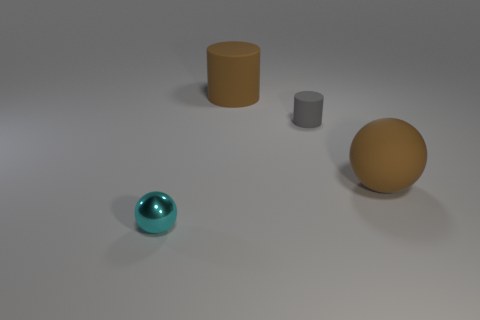Is there any other thing that is the same material as the small cyan sphere?
Offer a terse response. No. How many large cylinders are the same color as the large matte sphere?
Your answer should be compact. 1. Is the color of the large matte object in front of the large brown matte cylinder the same as the big matte cylinder?
Your answer should be very brief. Yes. There is a small cyan shiny object in front of the large brown rubber ball; what shape is it?
Provide a short and direct response. Sphere. Is there a rubber sphere on the left side of the large brown object that is behind the brown sphere?
Provide a short and direct response. No. What number of other small cylinders are made of the same material as the brown cylinder?
Your answer should be very brief. 1. What size is the brown object on the left side of the large rubber sphere that is to the right of the large brown rubber object behind the small matte thing?
Offer a very short reply. Large. How many cylinders are behind the tiny cylinder?
Your response must be concise. 1. Is the number of big brown objects greater than the number of large green metal cubes?
Provide a succinct answer. Yes. What size is the rubber object that is both to the left of the large matte sphere and on the right side of the big cylinder?
Make the answer very short. Small. 